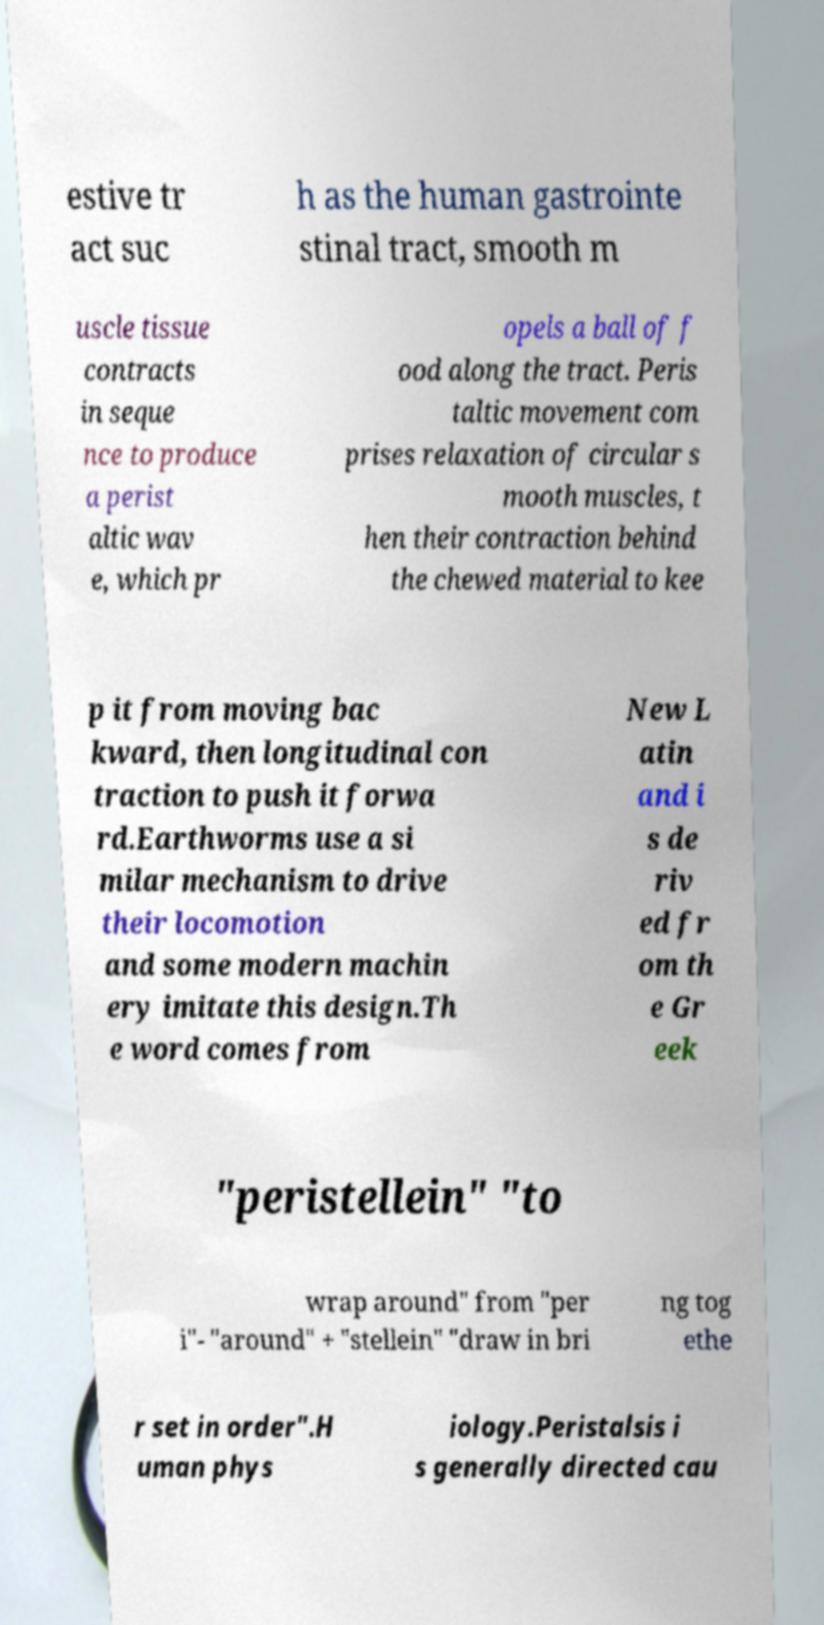Could you extract and type out the text from this image? estive tr act suc h as the human gastrointe stinal tract, smooth m uscle tissue contracts in seque nce to produce a perist altic wav e, which pr opels a ball of f ood along the tract. Peris taltic movement com prises relaxation of circular s mooth muscles, t hen their contraction behind the chewed material to kee p it from moving bac kward, then longitudinal con traction to push it forwa rd.Earthworms use a si milar mechanism to drive their locomotion and some modern machin ery imitate this design.Th e word comes from New L atin and i s de riv ed fr om th e Gr eek "peristellein" "to wrap around" from "per i"- "around" + "stellein" "draw in bri ng tog ethe r set in order".H uman phys iology.Peristalsis i s generally directed cau 